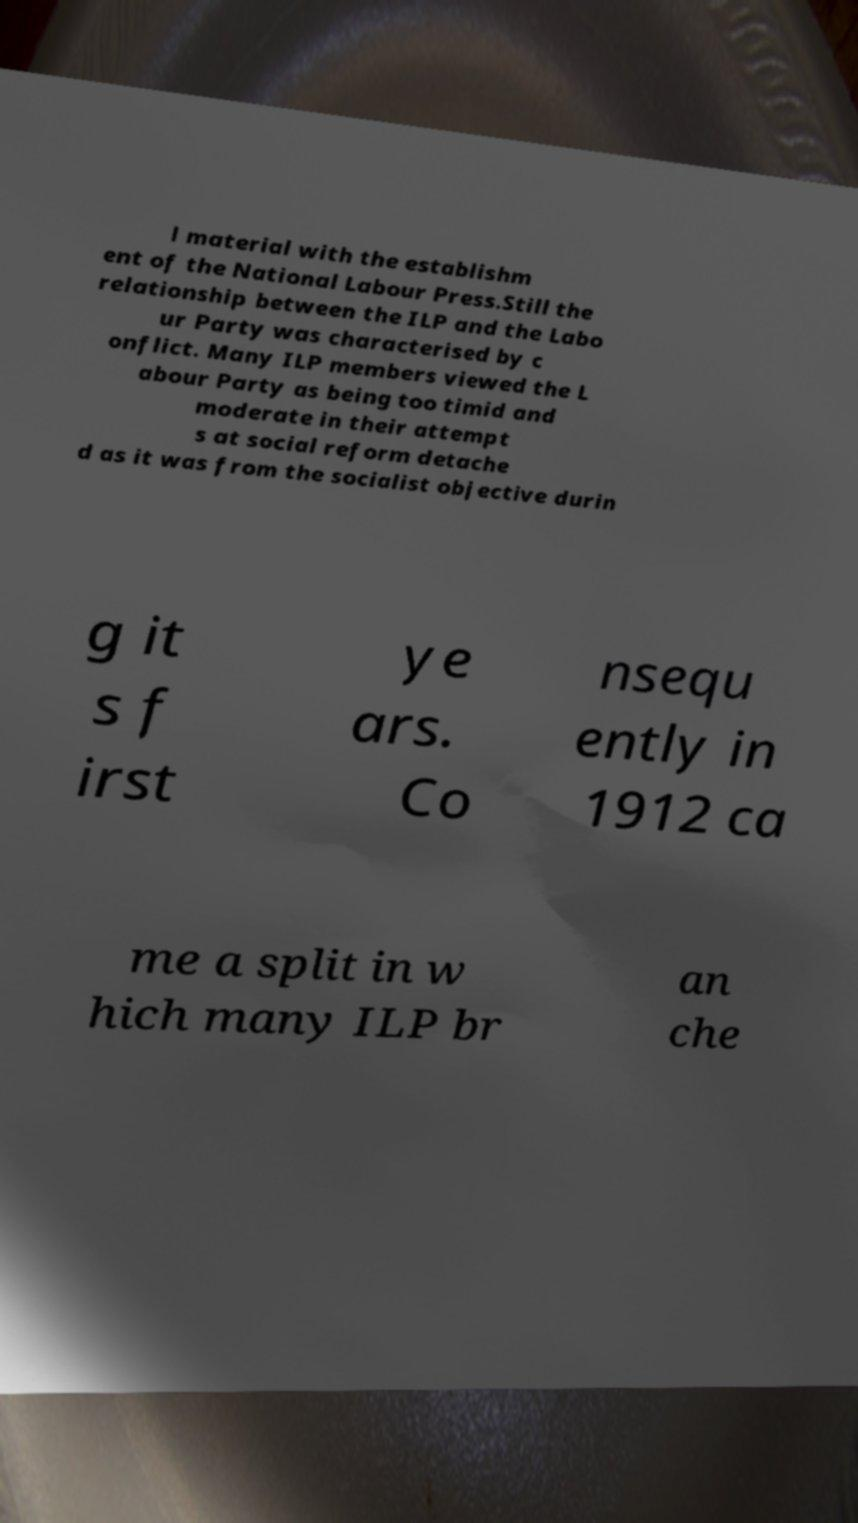For documentation purposes, I need the text within this image transcribed. Could you provide that? l material with the establishm ent of the National Labour Press.Still the relationship between the ILP and the Labo ur Party was characterised by c onflict. Many ILP members viewed the L abour Party as being too timid and moderate in their attempt s at social reform detache d as it was from the socialist objective durin g it s f irst ye ars. Co nsequ ently in 1912 ca me a split in w hich many ILP br an che 